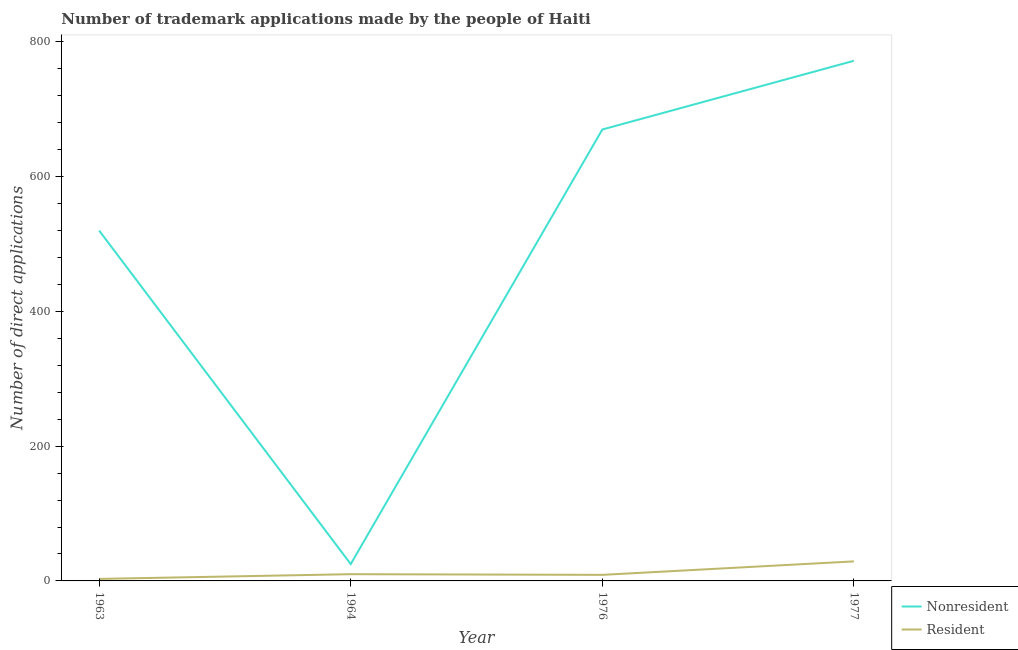What is the number of trademark applications made by non residents in 1963?
Provide a succinct answer. 520. Across all years, what is the maximum number of trademark applications made by non residents?
Give a very brief answer. 772. Across all years, what is the minimum number of trademark applications made by residents?
Offer a terse response. 3. In which year was the number of trademark applications made by residents minimum?
Offer a terse response. 1963. What is the total number of trademark applications made by residents in the graph?
Your response must be concise. 51. What is the difference between the number of trademark applications made by non residents in 1964 and that in 1976?
Your answer should be very brief. -645. What is the difference between the number of trademark applications made by non residents in 1964 and the number of trademark applications made by residents in 1963?
Provide a succinct answer. 22. What is the average number of trademark applications made by non residents per year?
Your response must be concise. 496.75. In the year 1977, what is the difference between the number of trademark applications made by non residents and number of trademark applications made by residents?
Your response must be concise. 743. What is the ratio of the number of trademark applications made by residents in 1964 to that in 1976?
Offer a terse response. 1.11. Is the difference between the number of trademark applications made by residents in 1963 and 1976 greater than the difference between the number of trademark applications made by non residents in 1963 and 1976?
Offer a very short reply. Yes. What is the difference between the highest and the second highest number of trademark applications made by non residents?
Your answer should be compact. 102. What is the difference between the highest and the lowest number of trademark applications made by non residents?
Ensure brevity in your answer.  747. Is the sum of the number of trademark applications made by non residents in 1976 and 1977 greater than the maximum number of trademark applications made by residents across all years?
Keep it short and to the point. Yes. Is the number of trademark applications made by non residents strictly greater than the number of trademark applications made by residents over the years?
Keep it short and to the point. Yes. Is the number of trademark applications made by non residents strictly less than the number of trademark applications made by residents over the years?
Your answer should be compact. No. Are the values on the major ticks of Y-axis written in scientific E-notation?
Give a very brief answer. No. Where does the legend appear in the graph?
Your answer should be compact. Bottom right. What is the title of the graph?
Your response must be concise. Number of trademark applications made by the people of Haiti. What is the label or title of the Y-axis?
Provide a succinct answer. Number of direct applications. What is the Number of direct applications of Nonresident in 1963?
Provide a succinct answer. 520. What is the Number of direct applications in Resident in 1963?
Give a very brief answer. 3. What is the Number of direct applications in Nonresident in 1964?
Offer a terse response. 25. What is the Number of direct applications of Nonresident in 1976?
Your answer should be compact. 670. What is the Number of direct applications of Nonresident in 1977?
Offer a terse response. 772. What is the Number of direct applications of Resident in 1977?
Your answer should be very brief. 29. Across all years, what is the maximum Number of direct applications in Nonresident?
Your answer should be compact. 772. Across all years, what is the maximum Number of direct applications of Resident?
Provide a succinct answer. 29. Across all years, what is the minimum Number of direct applications of Nonresident?
Offer a terse response. 25. Across all years, what is the minimum Number of direct applications of Resident?
Your answer should be compact. 3. What is the total Number of direct applications in Nonresident in the graph?
Provide a short and direct response. 1987. What is the total Number of direct applications of Resident in the graph?
Make the answer very short. 51. What is the difference between the Number of direct applications in Nonresident in 1963 and that in 1964?
Offer a terse response. 495. What is the difference between the Number of direct applications of Nonresident in 1963 and that in 1976?
Provide a short and direct response. -150. What is the difference between the Number of direct applications in Nonresident in 1963 and that in 1977?
Give a very brief answer. -252. What is the difference between the Number of direct applications of Resident in 1963 and that in 1977?
Offer a terse response. -26. What is the difference between the Number of direct applications in Nonresident in 1964 and that in 1976?
Ensure brevity in your answer.  -645. What is the difference between the Number of direct applications of Nonresident in 1964 and that in 1977?
Your answer should be very brief. -747. What is the difference between the Number of direct applications of Resident in 1964 and that in 1977?
Keep it short and to the point. -19. What is the difference between the Number of direct applications of Nonresident in 1976 and that in 1977?
Your answer should be very brief. -102. What is the difference between the Number of direct applications in Nonresident in 1963 and the Number of direct applications in Resident in 1964?
Offer a very short reply. 510. What is the difference between the Number of direct applications of Nonresident in 1963 and the Number of direct applications of Resident in 1976?
Give a very brief answer. 511. What is the difference between the Number of direct applications in Nonresident in 1963 and the Number of direct applications in Resident in 1977?
Ensure brevity in your answer.  491. What is the difference between the Number of direct applications in Nonresident in 1976 and the Number of direct applications in Resident in 1977?
Your answer should be very brief. 641. What is the average Number of direct applications in Nonresident per year?
Ensure brevity in your answer.  496.75. What is the average Number of direct applications of Resident per year?
Your answer should be very brief. 12.75. In the year 1963, what is the difference between the Number of direct applications of Nonresident and Number of direct applications of Resident?
Keep it short and to the point. 517. In the year 1976, what is the difference between the Number of direct applications in Nonresident and Number of direct applications in Resident?
Offer a very short reply. 661. In the year 1977, what is the difference between the Number of direct applications in Nonresident and Number of direct applications in Resident?
Provide a short and direct response. 743. What is the ratio of the Number of direct applications of Nonresident in 1963 to that in 1964?
Offer a terse response. 20.8. What is the ratio of the Number of direct applications in Nonresident in 1963 to that in 1976?
Offer a terse response. 0.78. What is the ratio of the Number of direct applications of Nonresident in 1963 to that in 1977?
Make the answer very short. 0.67. What is the ratio of the Number of direct applications of Resident in 1963 to that in 1977?
Give a very brief answer. 0.1. What is the ratio of the Number of direct applications of Nonresident in 1964 to that in 1976?
Your response must be concise. 0.04. What is the ratio of the Number of direct applications of Nonresident in 1964 to that in 1977?
Ensure brevity in your answer.  0.03. What is the ratio of the Number of direct applications in Resident in 1964 to that in 1977?
Give a very brief answer. 0.34. What is the ratio of the Number of direct applications of Nonresident in 1976 to that in 1977?
Your answer should be very brief. 0.87. What is the ratio of the Number of direct applications of Resident in 1976 to that in 1977?
Your answer should be very brief. 0.31. What is the difference between the highest and the second highest Number of direct applications in Nonresident?
Give a very brief answer. 102. What is the difference between the highest and the second highest Number of direct applications of Resident?
Keep it short and to the point. 19. What is the difference between the highest and the lowest Number of direct applications in Nonresident?
Offer a very short reply. 747. What is the difference between the highest and the lowest Number of direct applications in Resident?
Your answer should be compact. 26. 